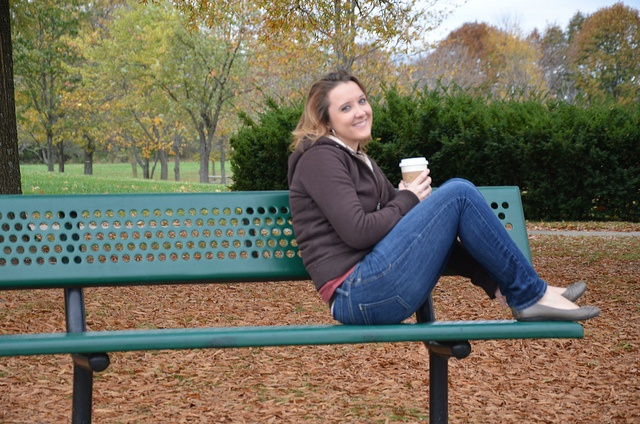Describe the objects in this image and their specific colors. I can see bench in black, teal, and gray tones, people in black, gray, navy, and darkblue tones, and cup in black, white, tan, and darkgray tones in this image. 